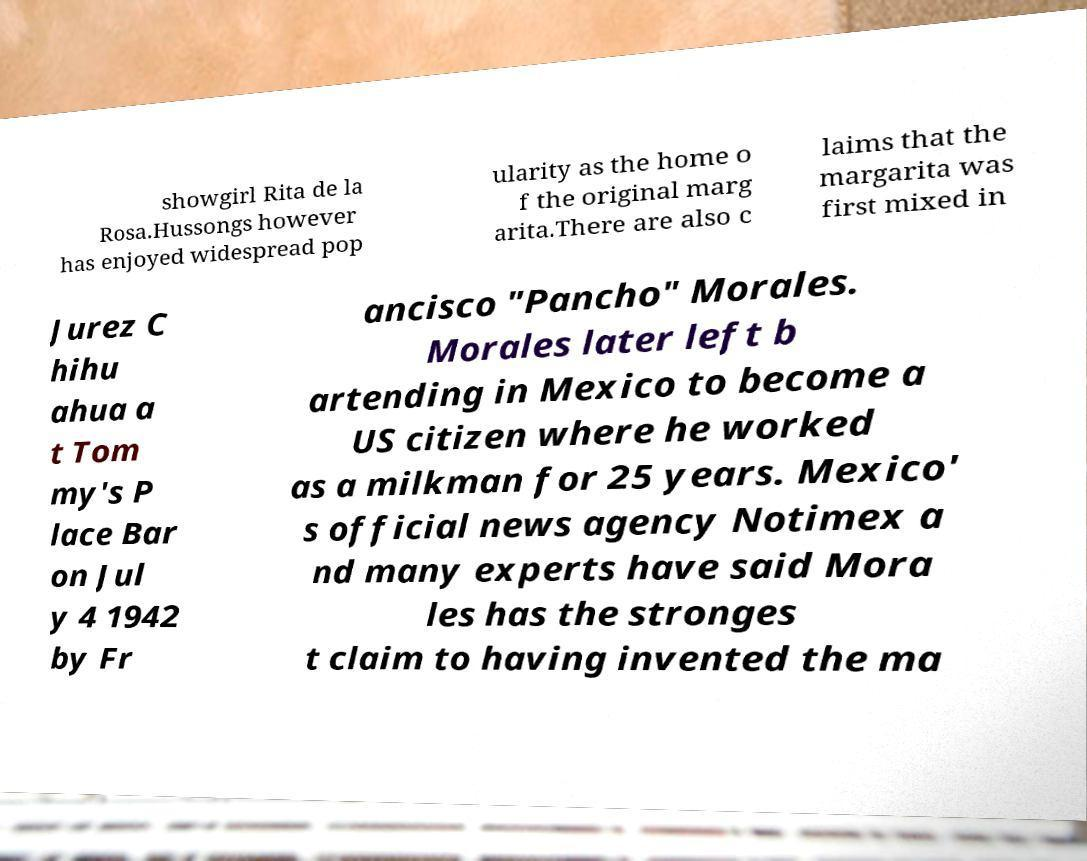Please read and relay the text visible in this image. What does it say? showgirl Rita de la Rosa.Hussongs however has enjoyed widespread pop ularity as the home o f the original marg arita.There are also c laims that the margarita was first mixed in Jurez C hihu ahua a t Tom my's P lace Bar on Jul y 4 1942 by Fr ancisco "Pancho" Morales. Morales later left b artending in Mexico to become a US citizen where he worked as a milkman for 25 years. Mexico' s official news agency Notimex a nd many experts have said Mora les has the stronges t claim to having invented the ma 